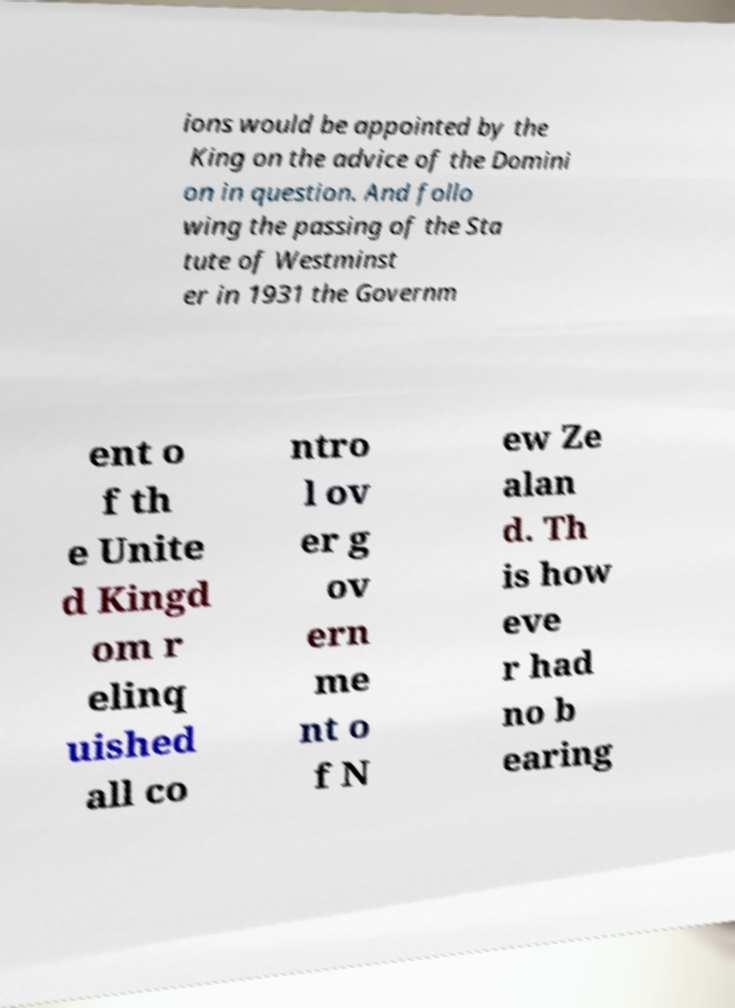Please read and relay the text visible in this image. What does it say? ions would be appointed by the King on the advice of the Domini on in question. And follo wing the passing of the Sta tute of Westminst er in 1931 the Governm ent o f th e Unite d Kingd om r elinq uished all co ntro l ov er g ov ern me nt o f N ew Ze alan d. Th is how eve r had no b earing 